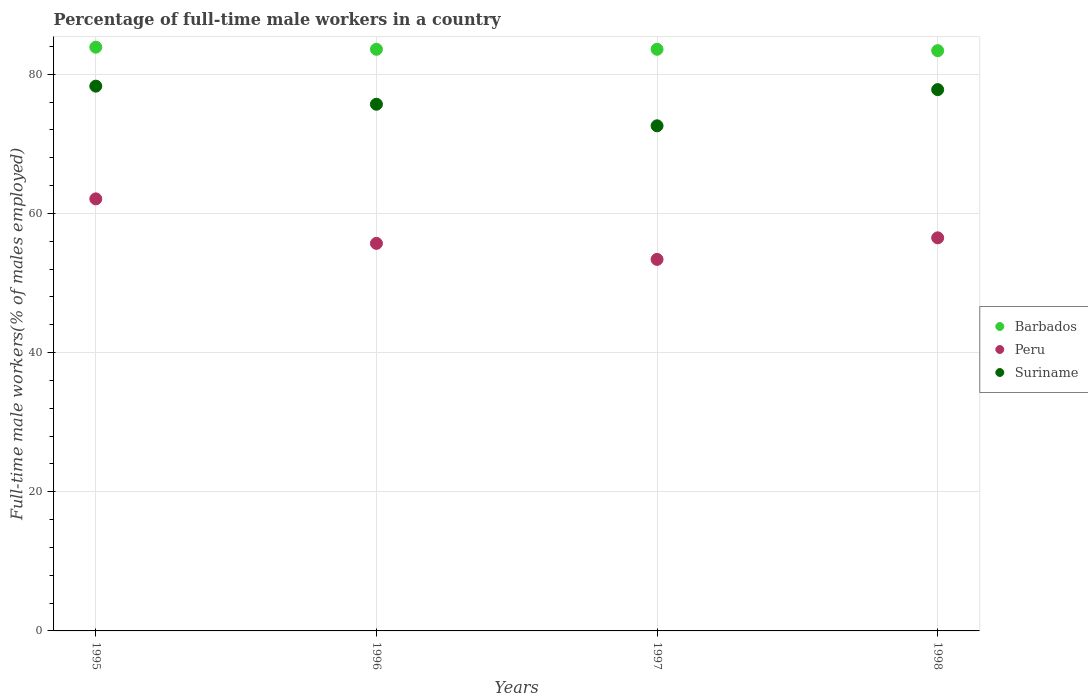How many different coloured dotlines are there?
Keep it short and to the point. 3. What is the percentage of full-time male workers in Barbados in 1996?
Provide a succinct answer. 83.6. Across all years, what is the maximum percentage of full-time male workers in Suriname?
Your response must be concise. 78.3. Across all years, what is the minimum percentage of full-time male workers in Peru?
Give a very brief answer. 53.4. In which year was the percentage of full-time male workers in Suriname minimum?
Provide a short and direct response. 1997. What is the total percentage of full-time male workers in Barbados in the graph?
Keep it short and to the point. 334.5. What is the difference between the percentage of full-time male workers in Peru in 1997 and that in 1998?
Make the answer very short. -3.1. What is the difference between the percentage of full-time male workers in Suriname in 1998 and the percentage of full-time male workers in Peru in 1996?
Provide a short and direct response. 22.1. What is the average percentage of full-time male workers in Suriname per year?
Your response must be concise. 76.1. In the year 1998, what is the difference between the percentage of full-time male workers in Barbados and percentage of full-time male workers in Suriname?
Give a very brief answer. 5.6. In how many years, is the percentage of full-time male workers in Suriname greater than 8 %?
Your response must be concise. 4. What is the ratio of the percentage of full-time male workers in Peru in 1997 to that in 1998?
Make the answer very short. 0.95. What is the difference between the highest and the second highest percentage of full-time male workers in Barbados?
Make the answer very short. 0.3. What is the difference between the highest and the lowest percentage of full-time male workers in Suriname?
Provide a succinct answer. 5.7. Is the sum of the percentage of full-time male workers in Peru in 1995 and 1998 greater than the maximum percentage of full-time male workers in Barbados across all years?
Make the answer very short. Yes. Does the percentage of full-time male workers in Suriname monotonically increase over the years?
Offer a very short reply. No. How many dotlines are there?
Your answer should be compact. 3. How many years are there in the graph?
Make the answer very short. 4. What is the difference between two consecutive major ticks on the Y-axis?
Offer a terse response. 20. Are the values on the major ticks of Y-axis written in scientific E-notation?
Provide a succinct answer. No. Does the graph contain grids?
Your answer should be compact. Yes. What is the title of the graph?
Give a very brief answer. Percentage of full-time male workers in a country. What is the label or title of the Y-axis?
Your answer should be compact. Full-time male workers(% of males employed). What is the Full-time male workers(% of males employed) of Barbados in 1995?
Your response must be concise. 83.9. What is the Full-time male workers(% of males employed) in Peru in 1995?
Provide a short and direct response. 62.1. What is the Full-time male workers(% of males employed) of Suriname in 1995?
Ensure brevity in your answer.  78.3. What is the Full-time male workers(% of males employed) in Barbados in 1996?
Offer a very short reply. 83.6. What is the Full-time male workers(% of males employed) of Peru in 1996?
Your answer should be very brief. 55.7. What is the Full-time male workers(% of males employed) of Suriname in 1996?
Offer a very short reply. 75.7. What is the Full-time male workers(% of males employed) in Barbados in 1997?
Keep it short and to the point. 83.6. What is the Full-time male workers(% of males employed) in Peru in 1997?
Your answer should be compact. 53.4. What is the Full-time male workers(% of males employed) of Suriname in 1997?
Provide a short and direct response. 72.6. What is the Full-time male workers(% of males employed) in Barbados in 1998?
Provide a succinct answer. 83.4. What is the Full-time male workers(% of males employed) in Peru in 1998?
Provide a short and direct response. 56.5. What is the Full-time male workers(% of males employed) in Suriname in 1998?
Your answer should be very brief. 77.8. Across all years, what is the maximum Full-time male workers(% of males employed) in Barbados?
Offer a terse response. 83.9. Across all years, what is the maximum Full-time male workers(% of males employed) of Peru?
Ensure brevity in your answer.  62.1. Across all years, what is the maximum Full-time male workers(% of males employed) in Suriname?
Your response must be concise. 78.3. Across all years, what is the minimum Full-time male workers(% of males employed) of Barbados?
Your response must be concise. 83.4. Across all years, what is the minimum Full-time male workers(% of males employed) of Peru?
Your response must be concise. 53.4. Across all years, what is the minimum Full-time male workers(% of males employed) in Suriname?
Make the answer very short. 72.6. What is the total Full-time male workers(% of males employed) in Barbados in the graph?
Ensure brevity in your answer.  334.5. What is the total Full-time male workers(% of males employed) in Peru in the graph?
Make the answer very short. 227.7. What is the total Full-time male workers(% of males employed) in Suriname in the graph?
Your answer should be very brief. 304.4. What is the difference between the Full-time male workers(% of males employed) in Peru in 1995 and that in 1996?
Your answer should be compact. 6.4. What is the difference between the Full-time male workers(% of males employed) of Suriname in 1995 and that in 1996?
Your response must be concise. 2.6. What is the difference between the Full-time male workers(% of males employed) in Barbados in 1995 and that in 1997?
Offer a terse response. 0.3. What is the difference between the Full-time male workers(% of males employed) of Peru in 1995 and that in 1997?
Provide a succinct answer. 8.7. What is the difference between the Full-time male workers(% of males employed) of Barbados in 1995 and that in 1998?
Your answer should be compact. 0.5. What is the difference between the Full-time male workers(% of males employed) of Peru in 1995 and that in 1998?
Provide a succinct answer. 5.6. What is the difference between the Full-time male workers(% of males employed) in Suriname in 1995 and that in 1998?
Your answer should be compact. 0.5. What is the difference between the Full-time male workers(% of males employed) of Barbados in 1996 and that in 1998?
Provide a short and direct response. 0.2. What is the difference between the Full-time male workers(% of males employed) of Peru in 1996 and that in 1998?
Your answer should be very brief. -0.8. What is the difference between the Full-time male workers(% of males employed) of Barbados in 1997 and that in 1998?
Your response must be concise. 0.2. What is the difference between the Full-time male workers(% of males employed) in Barbados in 1995 and the Full-time male workers(% of males employed) in Peru in 1996?
Provide a short and direct response. 28.2. What is the difference between the Full-time male workers(% of males employed) in Barbados in 1995 and the Full-time male workers(% of males employed) in Suriname in 1996?
Offer a very short reply. 8.2. What is the difference between the Full-time male workers(% of males employed) of Barbados in 1995 and the Full-time male workers(% of males employed) of Peru in 1997?
Your answer should be very brief. 30.5. What is the difference between the Full-time male workers(% of males employed) in Barbados in 1995 and the Full-time male workers(% of males employed) in Suriname in 1997?
Your answer should be very brief. 11.3. What is the difference between the Full-time male workers(% of males employed) in Barbados in 1995 and the Full-time male workers(% of males employed) in Peru in 1998?
Make the answer very short. 27.4. What is the difference between the Full-time male workers(% of males employed) of Peru in 1995 and the Full-time male workers(% of males employed) of Suriname in 1998?
Provide a short and direct response. -15.7. What is the difference between the Full-time male workers(% of males employed) of Barbados in 1996 and the Full-time male workers(% of males employed) of Peru in 1997?
Your answer should be compact. 30.2. What is the difference between the Full-time male workers(% of males employed) in Barbados in 1996 and the Full-time male workers(% of males employed) in Suriname in 1997?
Give a very brief answer. 11. What is the difference between the Full-time male workers(% of males employed) in Peru in 1996 and the Full-time male workers(% of males employed) in Suriname in 1997?
Your answer should be compact. -16.9. What is the difference between the Full-time male workers(% of males employed) of Barbados in 1996 and the Full-time male workers(% of males employed) of Peru in 1998?
Provide a short and direct response. 27.1. What is the difference between the Full-time male workers(% of males employed) of Barbados in 1996 and the Full-time male workers(% of males employed) of Suriname in 1998?
Your response must be concise. 5.8. What is the difference between the Full-time male workers(% of males employed) in Peru in 1996 and the Full-time male workers(% of males employed) in Suriname in 1998?
Ensure brevity in your answer.  -22.1. What is the difference between the Full-time male workers(% of males employed) in Barbados in 1997 and the Full-time male workers(% of males employed) in Peru in 1998?
Make the answer very short. 27.1. What is the difference between the Full-time male workers(% of males employed) of Peru in 1997 and the Full-time male workers(% of males employed) of Suriname in 1998?
Ensure brevity in your answer.  -24.4. What is the average Full-time male workers(% of males employed) in Barbados per year?
Offer a terse response. 83.62. What is the average Full-time male workers(% of males employed) of Peru per year?
Your response must be concise. 56.92. What is the average Full-time male workers(% of males employed) in Suriname per year?
Make the answer very short. 76.1. In the year 1995, what is the difference between the Full-time male workers(% of males employed) of Barbados and Full-time male workers(% of males employed) of Peru?
Ensure brevity in your answer.  21.8. In the year 1995, what is the difference between the Full-time male workers(% of males employed) in Barbados and Full-time male workers(% of males employed) in Suriname?
Your answer should be very brief. 5.6. In the year 1995, what is the difference between the Full-time male workers(% of males employed) in Peru and Full-time male workers(% of males employed) in Suriname?
Your response must be concise. -16.2. In the year 1996, what is the difference between the Full-time male workers(% of males employed) of Barbados and Full-time male workers(% of males employed) of Peru?
Your response must be concise. 27.9. In the year 1996, what is the difference between the Full-time male workers(% of males employed) in Barbados and Full-time male workers(% of males employed) in Suriname?
Your answer should be very brief. 7.9. In the year 1997, what is the difference between the Full-time male workers(% of males employed) of Barbados and Full-time male workers(% of males employed) of Peru?
Your response must be concise. 30.2. In the year 1997, what is the difference between the Full-time male workers(% of males employed) in Peru and Full-time male workers(% of males employed) in Suriname?
Your response must be concise. -19.2. In the year 1998, what is the difference between the Full-time male workers(% of males employed) of Barbados and Full-time male workers(% of males employed) of Peru?
Your answer should be compact. 26.9. In the year 1998, what is the difference between the Full-time male workers(% of males employed) in Barbados and Full-time male workers(% of males employed) in Suriname?
Ensure brevity in your answer.  5.6. In the year 1998, what is the difference between the Full-time male workers(% of males employed) of Peru and Full-time male workers(% of males employed) of Suriname?
Offer a terse response. -21.3. What is the ratio of the Full-time male workers(% of males employed) of Barbados in 1995 to that in 1996?
Offer a terse response. 1. What is the ratio of the Full-time male workers(% of males employed) in Peru in 1995 to that in 1996?
Ensure brevity in your answer.  1.11. What is the ratio of the Full-time male workers(% of males employed) of Suriname in 1995 to that in 1996?
Give a very brief answer. 1.03. What is the ratio of the Full-time male workers(% of males employed) of Barbados in 1995 to that in 1997?
Keep it short and to the point. 1. What is the ratio of the Full-time male workers(% of males employed) in Peru in 1995 to that in 1997?
Provide a short and direct response. 1.16. What is the ratio of the Full-time male workers(% of males employed) in Suriname in 1995 to that in 1997?
Your answer should be compact. 1.08. What is the ratio of the Full-time male workers(% of males employed) of Barbados in 1995 to that in 1998?
Your answer should be compact. 1.01. What is the ratio of the Full-time male workers(% of males employed) of Peru in 1995 to that in 1998?
Give a very brief answer. 1.1. What is the ratio of the Full-time male workers(% of males employed) in Suriname in 1995 to that in 1998?
Provide a succinct answer. 1.01. What is the ratio of the Full-time male workers(% of males employed) in Barbados in 1996 to that in 1997?
Keep it short and to the point. 1. What is the ratio of the Full-time male workers(% of males employed) of Peru in 1996 to that in 1997?
Provide a short and direct response. 1.04. What is the ratio of the Full-time male workers(% of males employed) in Suriname in 1996 to that in 1997?
Your response must be concise. 1.04. What is the ratio of the Full-time male workers(% of males employed) of Barbados in 1996 to that in 1998?
Your response must be concise. 1. What is the ratio of the Full-time male workers(% of males employed) in Peru in 1996 to that in 1998?
Ensure brevity in your answer.  0.99. What is the ratio of the Full-time male workers(% of males employed) in Peru in 1997 to that in 1998?
Your answer should be compact. 0.95. What is the ratio of the Full-time male workers(% of males employed) of Suriname in 1997 to that in 1998?
Give a very brief answer. 0.93. What is the difference between the highest and the second highest Full-time male workers(% of males employed) of Suriname?
Ensure brevity in your answer.  0.5. What is the difference between the highest and the lowest Full-time male workers(% of males employed) in Barbados?
Keep it short and to the point. 0.5. What is the difference between the highest and the lowest Full-time male workers(% of males employed) of Peru?
Ensure brevity in your answer.  8.7. What is the difference between the highest and the lowest Full-time male workers(% of males employed) in Suriname?
Offer a very short reply. 5.7. 